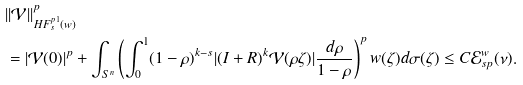<formula> <loc_0><loc_0><loc_500><loc_500>& | | { \mathcal { V } } | | _ { H F _ { s } ^ { p 1 } ( w ) } ^ { p } \\ & = | { \mathcal { V } } ( 0 ) | ^ { p } + \int _ { { S } ^ { n } } \left ( \int _ { 0 } ^ { 1 } ( 1 - \rho ) ^ { k - s } | ( I + R ) ^ { k } { \mathcal { V } } ( \rho \zeta ) | \frac { d \rho } { 1 - \rho } \right ) ^ { p } w ( \zeta ) d \sigma ( \zeta ) \leq C { \mathcal { E } } _ { s p } ^ { w } ( \nu ) .</formula> 